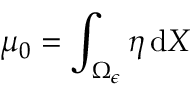<formula> <loc_0><loc_0><loc_500><loc_500>\mu _ { 0 } = \int _ { \Omega _ { \epsilon } } \eta \, d X</formula> 